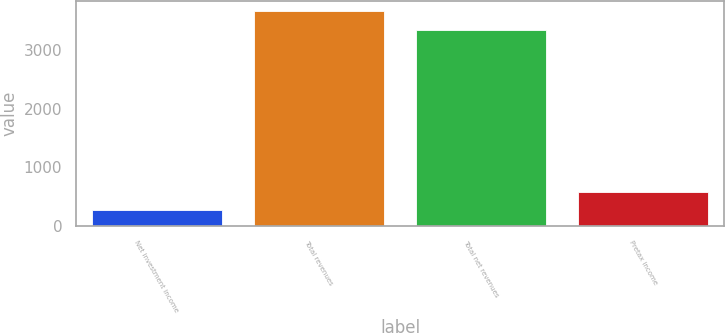<chart> <loc_0><loc_0><loc_500><loc_500><bar_chart><fcel>Net investment income<fcel>Total revenues<fcel>Total net revenues<fcel>Pretax income<nl><fcel>272<fcel>3655.7<fcel>3342<fcel>585.7<nl></chart> 